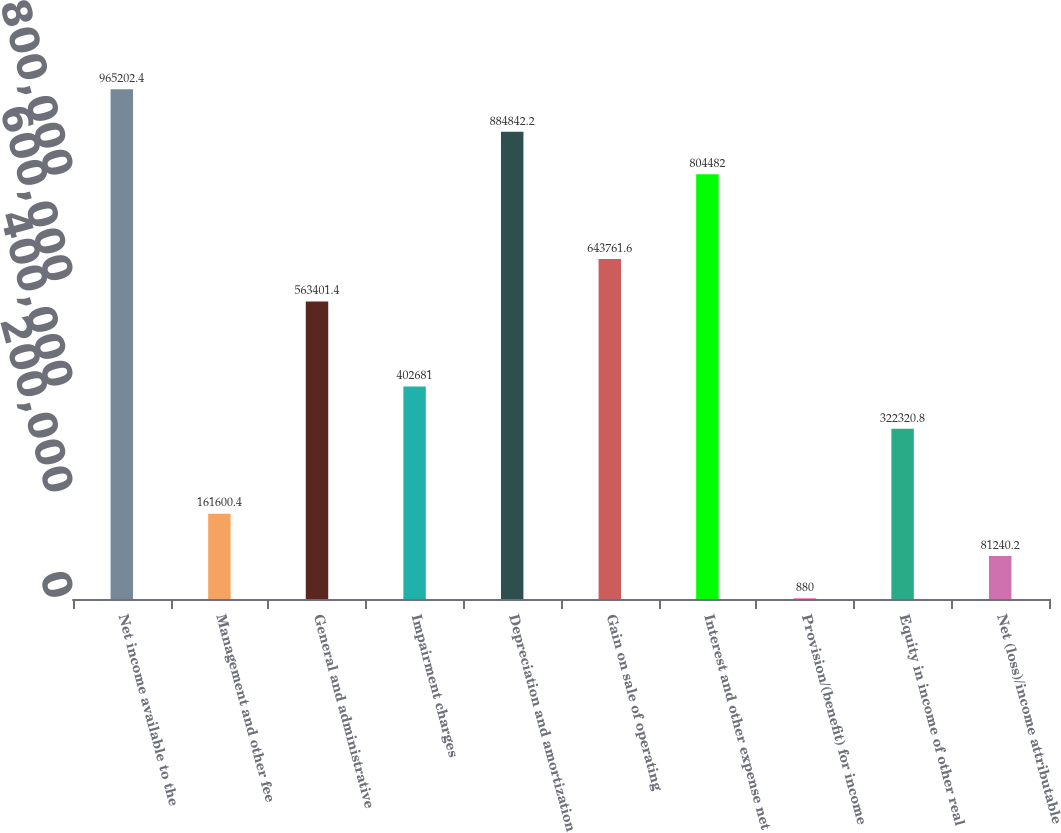<chart> <loc_0><loc_0><loc_500><loc_500><bar_chart><fcel>Net income available to the<fcel>Management and other fee<fcel>General and administrative<fcel>Impairment charges<fcel>Depreciation and amortization<fcel>Gain on sale of operating<fcel>Interest and other expense net<fcel>Provision/(benefit) for income<fcel>Equity in income of other real<fcel>Net (loss)/income attributable<nl><fcel>965202<fcel>161600<fcel>563401<fcel>402681<fcel>884842<fcel>643762<fcel>804482<fcel>880<fcel>322321<fcel>81240.2<nl></chart> 